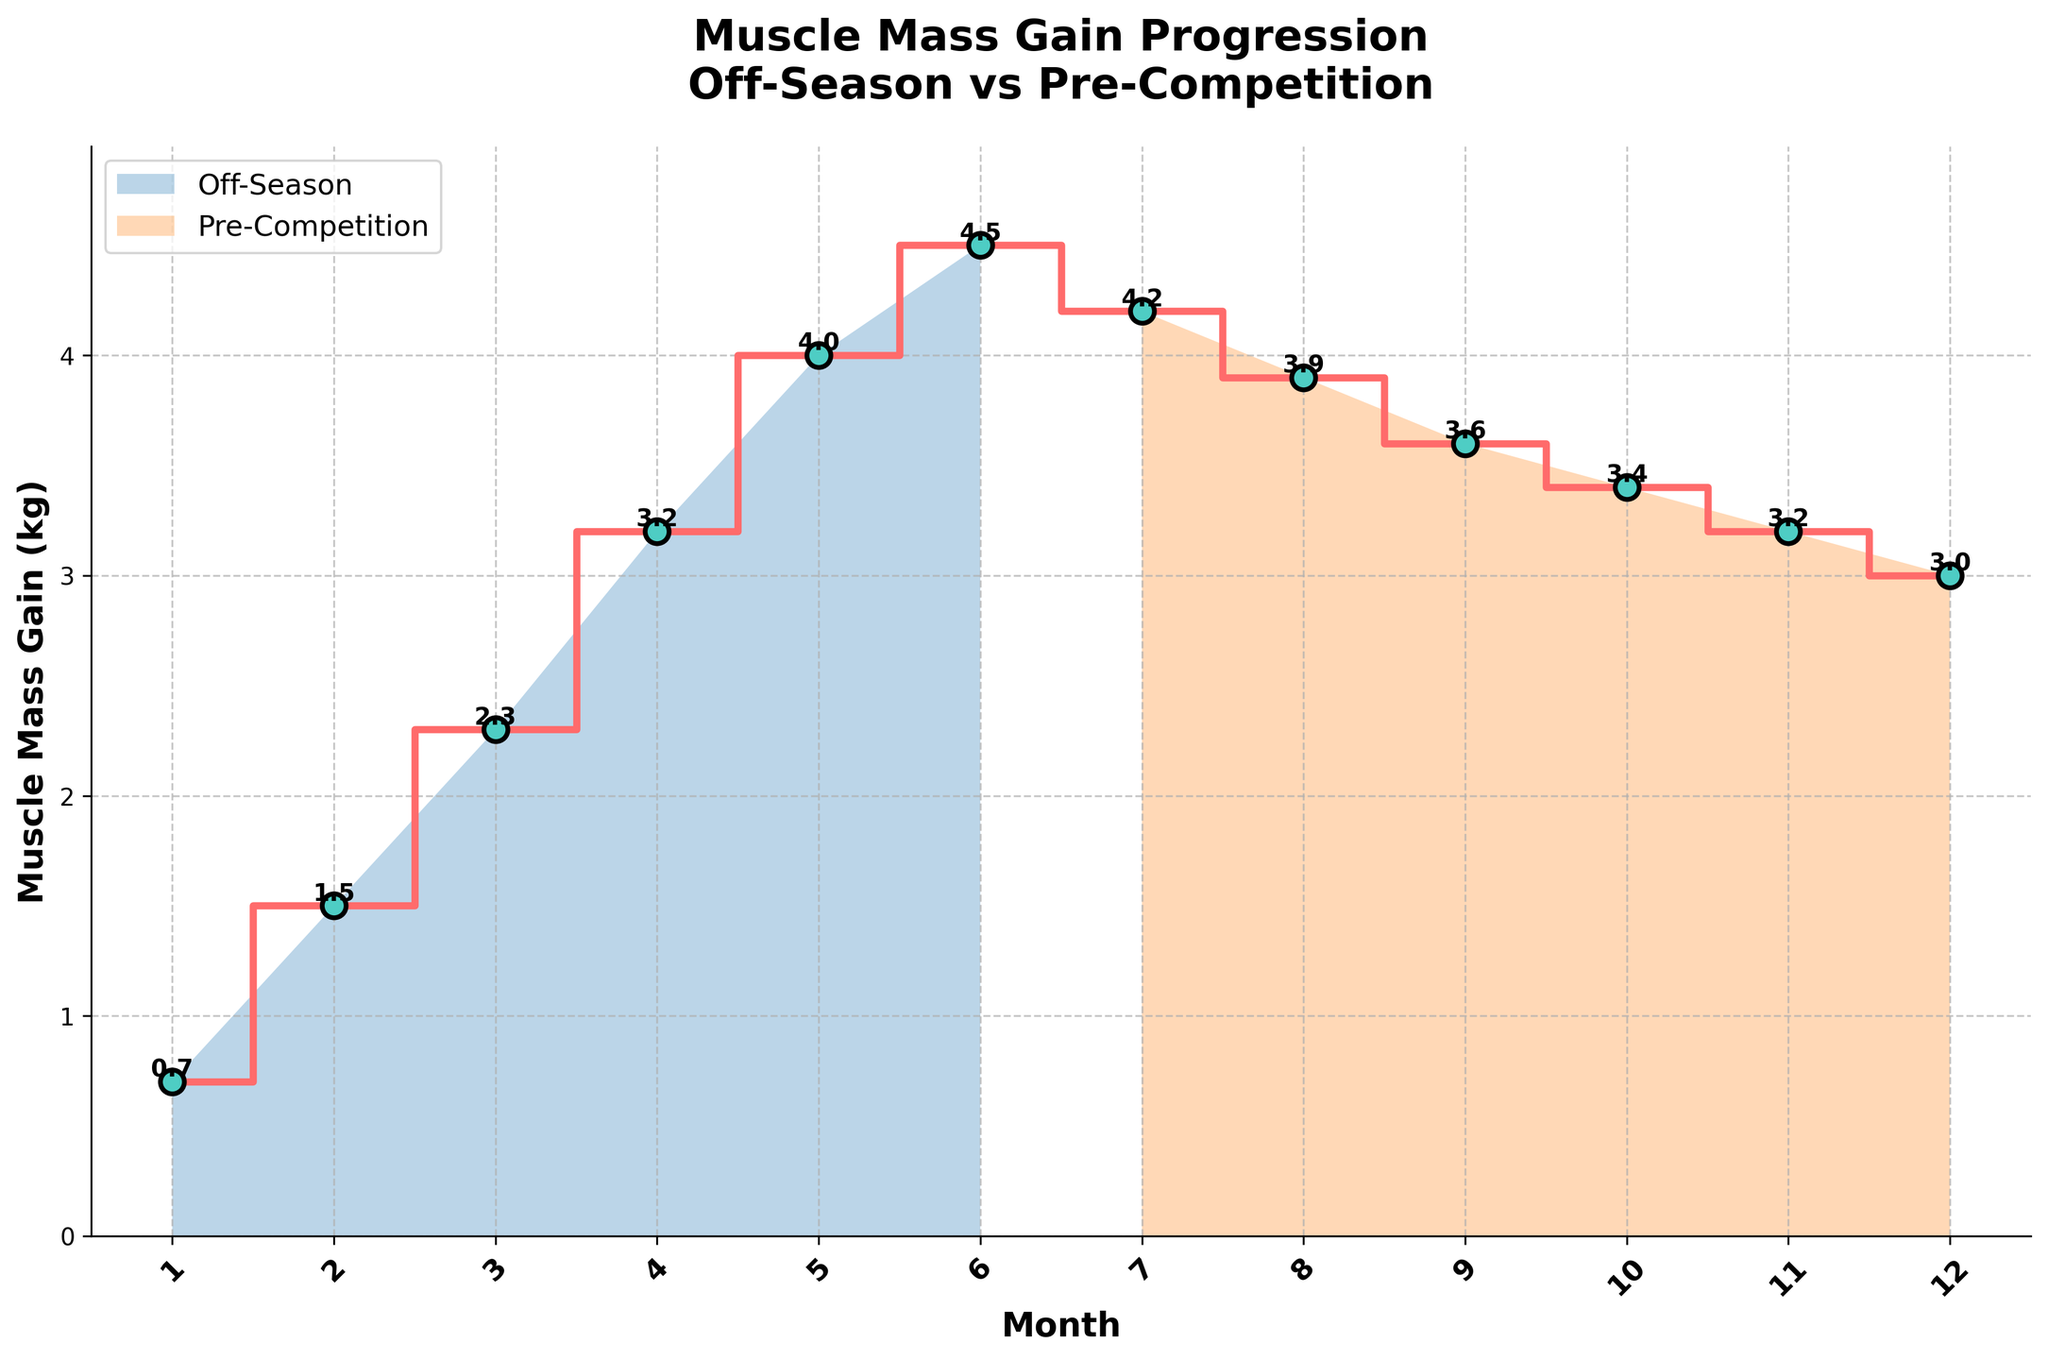What's the title of the figure? The title of the figure is displayed at the top of the plot. It helps to summarize what the plot is about.
Answer: Muscle Mass Gain Progression: Off-Season vs Pre-Competition What are the x-axis and y-axis labels? The labels of each axis are shown along the respective edges of the plot.
Answer: The x-axis is labeled 'Month' and the y-axis is labeled 'Muscle Mass Gain (kg)' Which training phase shows a higher peak muscle mass gain? By looking at the plot for the highest point (peak) and noting which training phase it occurs in, we can determine this. The peak occurs in the Off-Season phase.
Answer: Off-Season How does muscle mass gain change from Month 4 to Month 7? Determine the values of muscle mass gain at these points and observe the trend (increase, decrease, or stable). It decreases from 3.2 kg at Month 4 to 4.2 kg at Month 7.
Answer: It increases What is the overall trend of muscle mass gain during the Pre-Competition phase? Observe the series of data points corresponding to the Pre-Competition phase to understand the trend. The trend is a gradual decrease.
Answer: Gradual decrease What is the difference in muscle mass gain between Month 6 and Month 12? Subtract the muscle mass gain at Month 12 from the muscle mass gain at Month 6 to find the difference.
Answer: 4.5 kg - 3.0 kg = 1.5 kg Which phase has more consistent muscle mass gain, and how can you tell? Compare the variation (fluctuations) in the data points for each phase. Consistency can be seen when data points remain relatively close to each other.
Answer: Pre-Competition phase is more consistent (smaller variations) How many months during the Off-Season show a muscle mass gain of over 3 kg? Count the data points during the Off-Season phase that show muscle mass gain larger than 3 kg.
Answer: 3 months (Months 4, 5, and 6) On which month does the transition from Off-Season to Pre-Competition occur? Look for any visual cues or annotations on the x-axis indicating the change in training phase. There is a clear transition point.
Answer: Transition occurs between Month 6 and Month 7 What is the average muscle mass gain over the entire 12-month period? Sum all muscle mass gain values and then divide by the total number of months (12).
Answer: (0.7 + 1.5 + 2.3 + 3.2 + 4.0 + 4.5 + 4.2 + 3.9 + 3.6 + 3.4 + 3.2 + 3.0) / 12 = 3.325 kg 